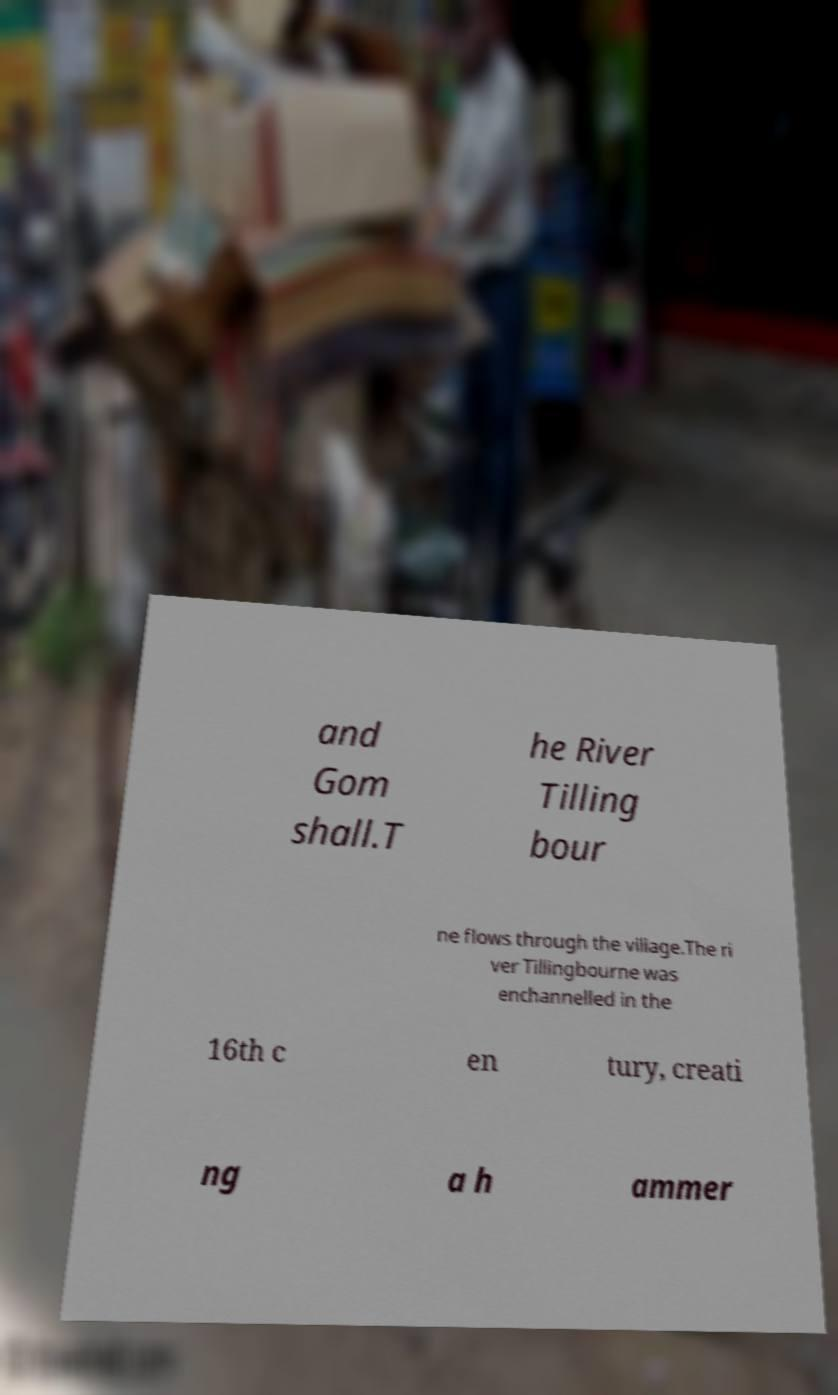There's text embedded in this image that I need extracted. Can you transcribe it verbatim? and Gom shall.T he River Tilling bour ne flows through the village.The ri ver Tillingbourne was enchannelled in the 16th c en tury, creati ng a h ammer 